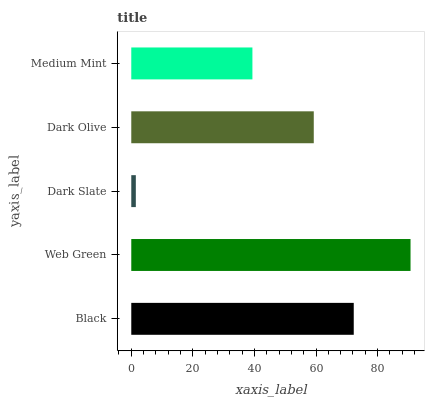Is Dark Slate the minimum?
Answer yes or no. Yes. Is Web Green the maximum?
Answer yes or no. Yes. Is Web Green the minimum?
Answer yes or no. No. Is Dark Slate the maximum?
Answer yes or no. No. Is Web Green greater than Dark Slate?
Answer yes or no. Yes. Is Dark Slate less than Web Green?
Answer yes or no. Yes. Is Dark Slate greater than Web Green?
Answer yes or no. No. Is Web Green less than Dark Slate?
Answer yes or no. No. Is Dark Olive the high median?
Answer yes or no. Yes. Is Dark Olive the low median?
Answer yes or no. Yes. Is Web Green the high median?
Answer yes or no. No. Is Dark Slate the low median?
Answer yes or no. No. 